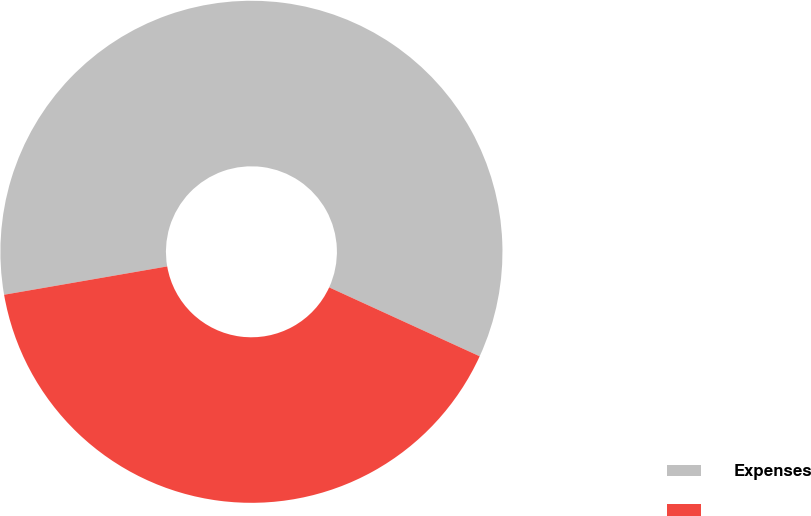Convert chart to OTSL. <chart><loc_0><loc_0><loc_500><loc_500><pie_chart><fcel>Expenses<fcel>Unnamed: 1<nl><fcel>59.57%<fcel>40.43%<nl></chart> 